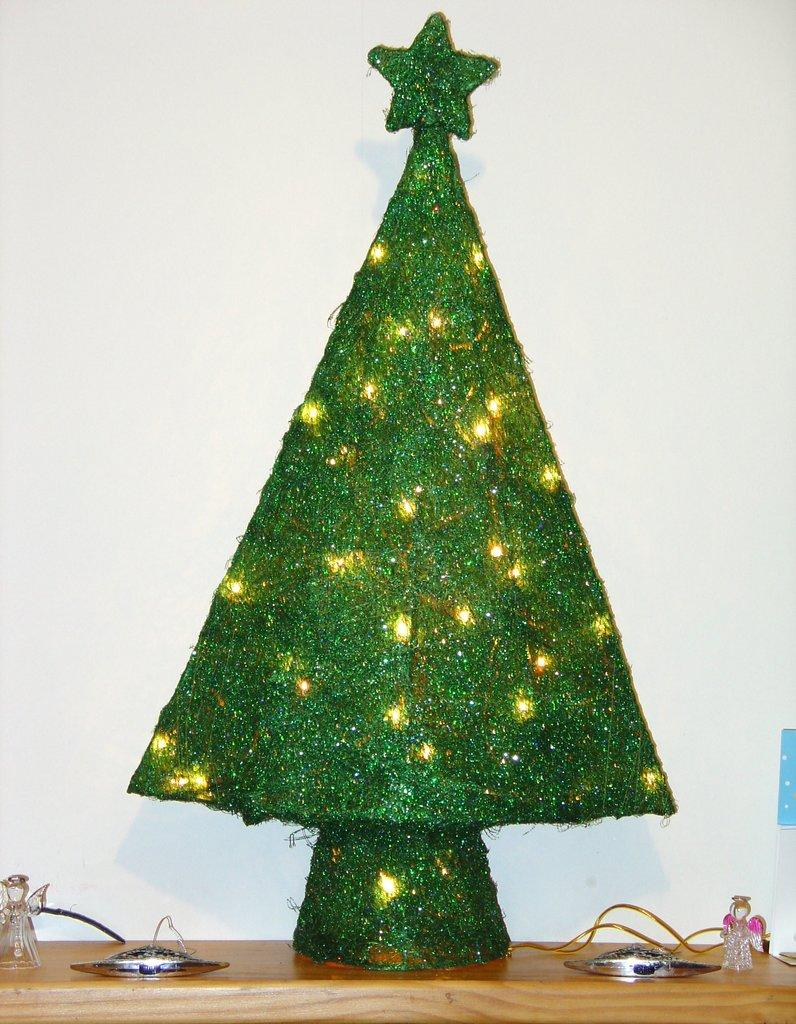What is placed on the table in the image? There is a decor placed on a table in the image. What can be seen in the background of the image? There is a wall in the background of the image. How many goldfish are swimming in the decor on the table? There are no goldfish present in the image; the decor on the table does not include any goldfish. 